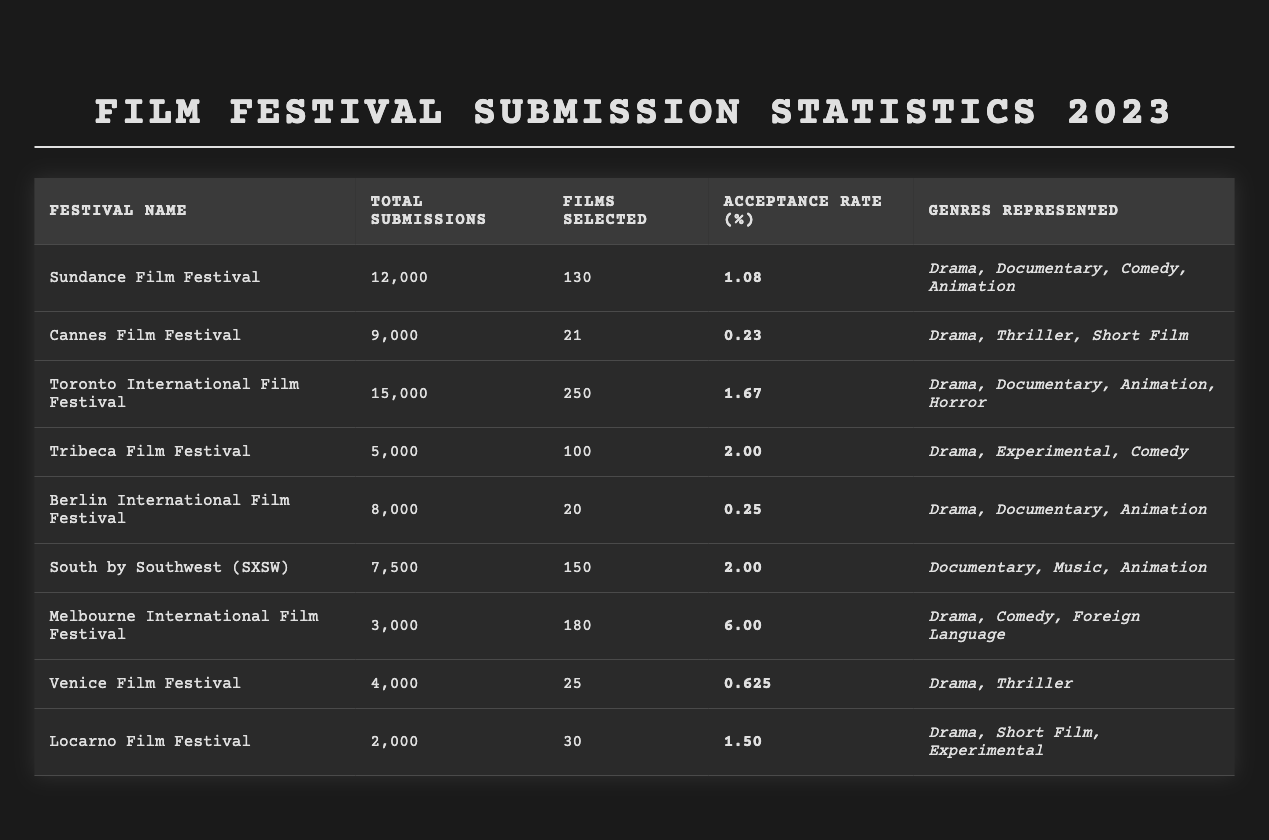What is the total number of submissions to the Toronto International Film Festival? The table shows that the total submissions listed for the Toronto International Film Festival are 15,000.
Answer: 15,000 Which film festival had the highest acceptance rate? The acceptance rates for each festival are listed, and the highest rate is 6.00% for the Melbourne International Film Festival.
Answer: Melbourne International Film Festival How many films were selected at the Cannes Film Festival? The table specifies that 21 films were selected for the Cannes Film Festival.
Answer: 21 What is the difference in the number of films selected between the Sundance Film Festival and the Tribeca Film Festival? Sundance had 130 films selected and Tribeca had 100. The difference is 130 - 100 = 30.
Answer: 30 What percentage of total submissions were accepted at the Berlin International Film Festival? Berlin had 8,000 submissions and 20 films selected. The acceptance rate is (20/8000) * 100 = 0.25%.
Answer: 0.25 Which genres were represented in the submitted films for both the Sundance and Toronto International Film Festivals? Both festivals represented the genres Drama and Animation according to the genres listed in the table.
Answer: Drama, Animation How many total films were selected across all listed festivals? To find the total selections, add the number of films selected: 130 + 21 + 250 + 100 + 20 + 150 + 180 + 25 + 30 = 906.
Answer: 906 Is the acceptance rate for SXSW higher than that for the Venice Film Festival? SXSW has an acceptance rate of 2.00% while Venice has 0.625%, indicating that SXSW's rate is higher.
Answer: Yes Among the listed festivals, which has the lowest total submissions? The table indicates that the festival with the lowest total submissions is the Locarno Film Festival with 2,000 submissions.
Answer: Locarno Film Festival Find the average acceptance rate of the festivals listed in the table. Add up the acceptance rates: 1.08 + 0.23 + 1.67 + 2.00 + 0.25 + 2.00 + 6.00 + 0.625 + 1.50 = 15.08. There are 9 festivals, so the average is 15.08 / 9 ≈ 1.68.
Answer: 1.68 Which festival had the highest number of total submissions and how many were submitted? The Toronto International Film Festival had the highest submissions with a total of 15,000.
Answer: Toronto International Film Festival, 15,000 